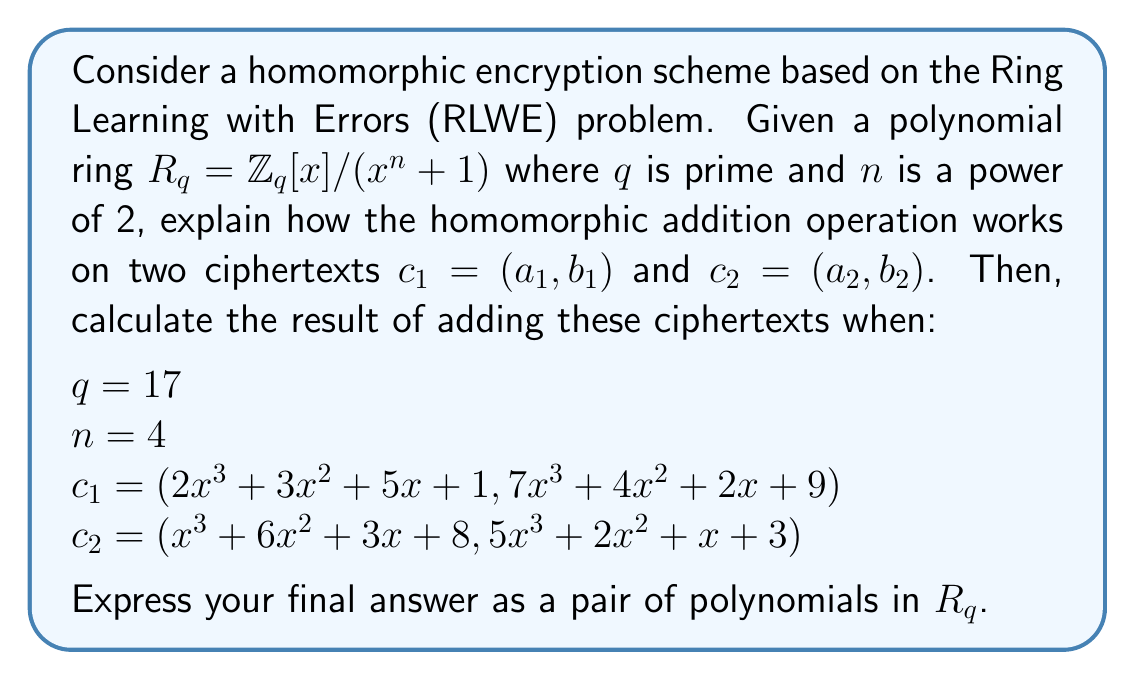Give your solution to this math problem. To solve this problem, we need to understand the homomorphic addition operation in RLWE-based schemes and then apply it to the given ciphertexts.

Step 1: Homomorphic addition in RLWE-based schemes
In RLWE-based homomorphic encryption, ciphertexts are typically represented as pairs of polynomials in the ring $R_q$. The homomorphic addition of two ciphertexts $c_1 = (a_1, b_1)$ and $c_2 = (a_2, b_2)$ is performed component-wise:

$c_{add} = c_1 + c_2 = (a_1 + a_2, b_1 + b_2)$

Where the addition of polynomials is done coefficient-wise modulo $q$.

Step 2: Adding the given ciphertexts
We need to add $c_1 = (2x^3 + 3x^2 + 5x + 1, 7x^3 + 4x^2 + 2x + 9)$ and $c_2 = (x^3 + 6x^2 + 3x + 8, 5x^3 + 2x^2 + x + 3)$

For the first component:
$a_1 + a_2 = (2x^3 + 3x^2 + 5x + 1) + (x^3 + 6x^2 + 3x + 8)$
$= 3x^3 + 9x^2 + 8x + 9$

For the second component:
$b_1 + b_2 = (7x^3 + 4x^2 + 2x + 9) + (5x^3 + 2x^2 + x + 3)$
$= 12x^3 + 6x^2 + 3x + 12$

Step 3: Reducing modulo $q$ and $x^n + 1$
We need to reduce the coefficients modulo $q = 17$ and the polynomials modulo $x^n + 1 = x^4 + 1$.

For $a_1 + a_2$:
$3x^3 + 9x^2 + 8x + 9 \pmod{17} \equiv 3x^3 + 9x^2 + 8x + 9$

For $b_1 + b_2$:
$12x^3 + 6x^2 + 3x + 12 \pmod{17} \equiv 12x^3 + 6x^2 + 3x + 12$

No further reduction is needed as the degree of both polynomials is less than 4.

Therefore, the final result of the homomorphic addition is:
$c_{add} = (3x^3 + 9x^2 + 8x + 9, 12x^3 + 6x^2 + 3x + 12)$
Answer: $(3x^3 + 9x^2 + 8x + 9, 12x^3 + 6x^2 + 3x + 12)$ 